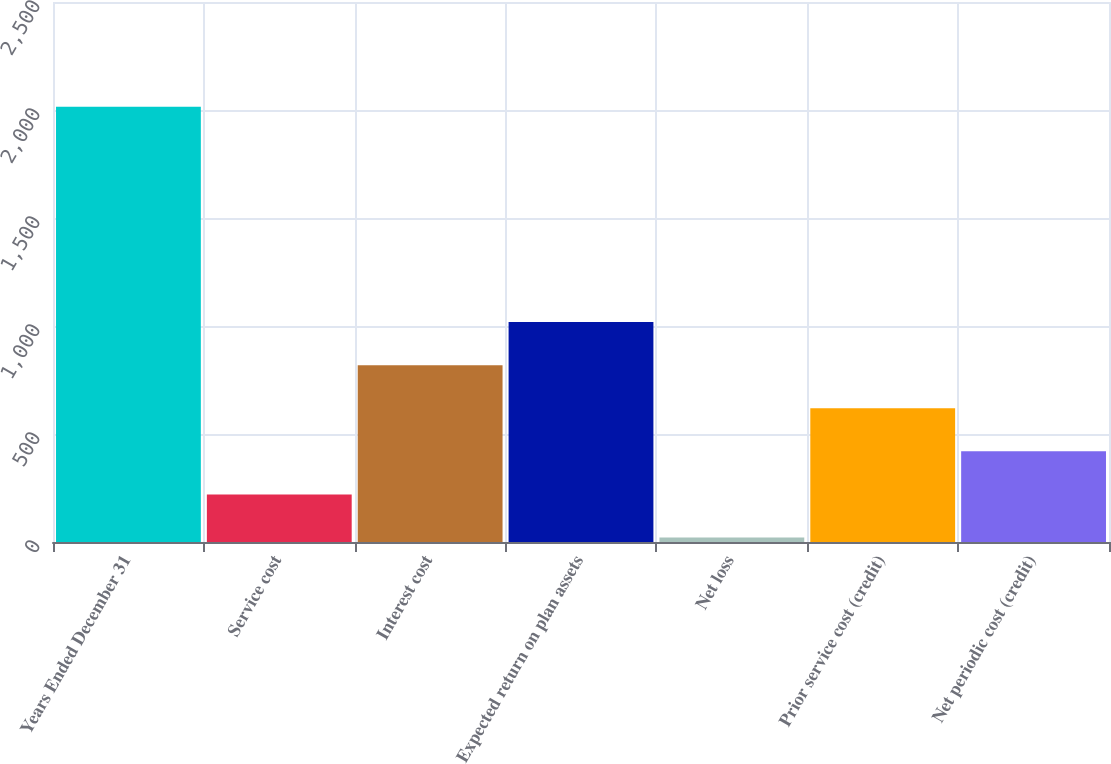<chart> <loc_0><loc_0><loc_500><loc_500><bar_chart><fcel>Years Ended December 31<fcel>Service cost<fcel>Interest cost<fcel>Expected return on plan assets<fcel>Net loss<fcel>Prior service cost (credit)<fcel>Net periodic cost (credit)<nl><fcel>2015<fcel>220.4<fcel>818.6<fcel>1018<fcel>21<fcel>619.2<fcel>419.8<nl></chart> 